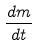<formula> <loc_0><loc_0><loc_500><loc_500>\frac { d m } { d t }</formula> 